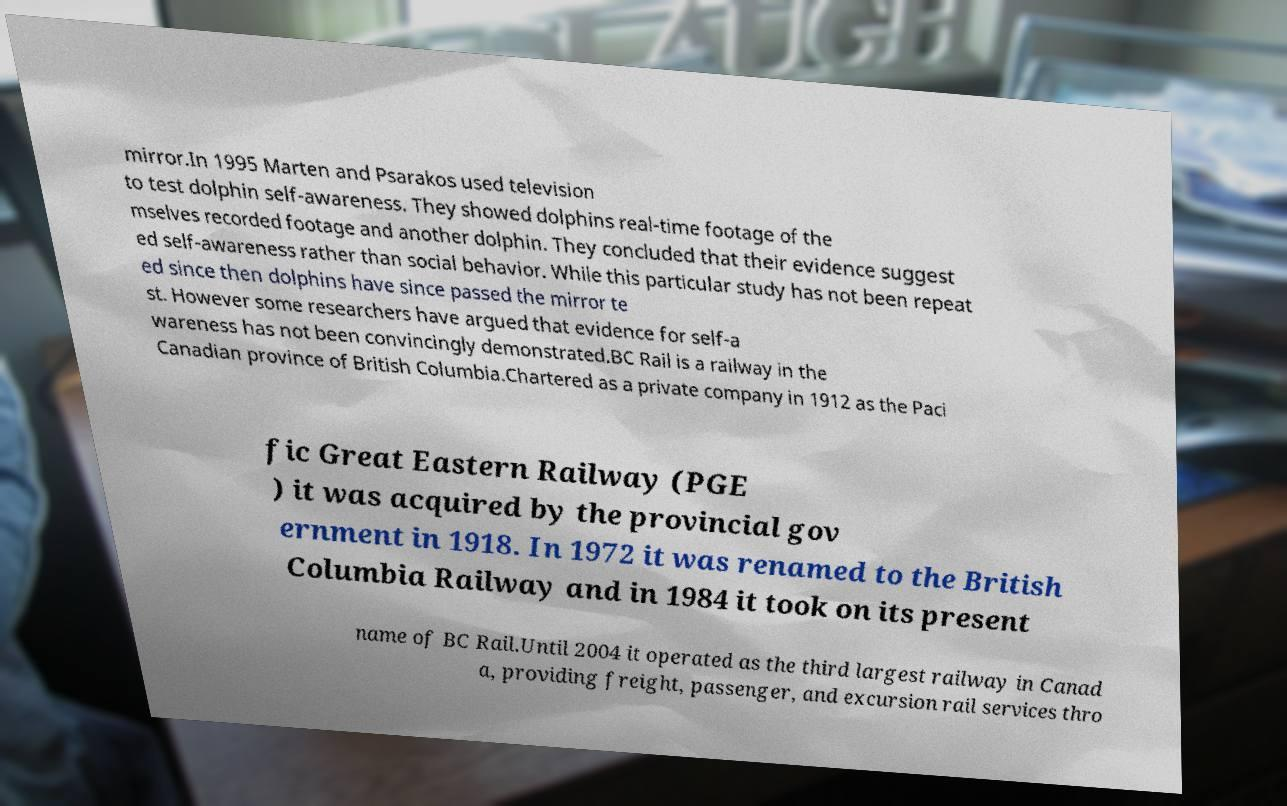There's text embedded in this image that I need extracted. Can you transcribe it verbatim? mirror.In 1995 Marten and Psarakos used television to test dolphin self-awareness. They showed dolphins real-time footage of the mselves recorded footage and another dolphin. They concluded that their evidence suggest ed self-awareness rather than social behavior. While this particular study has not been repeat ed since then dolphins have since passed the mirror te st. However some researchers have argued that evidence for self-a wareness has not been convincingly demonstrated.BC Rail is a railway in the Canadian province of British Columbia.Chartered as a private company in 1912 as the Paci fic Great Eastern Railway (PGE ) it was acquired by the provincial gov ernment in 1918. In 1972 it was renamed to the British Columbia Railway and in 1984 it took on its present name of BC Rail.Until 2004 it operated as the third largest railway in Canad a, providing freight, passenger, and excursion rail services thro 